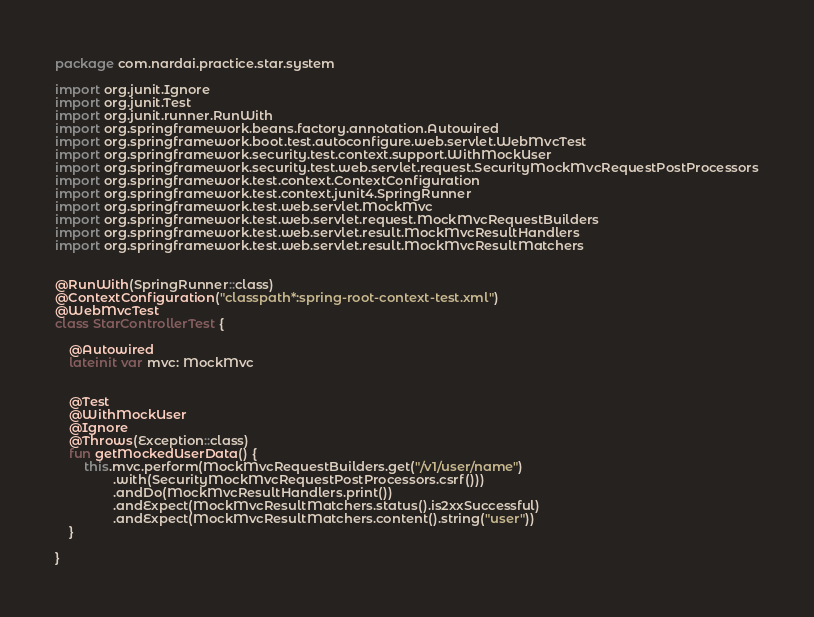<code> <loc_0><loc_0><loc_500><loc_500><_Kotlin_>package com.nardai.practice.star.system

import org.junit.Ignore
import org.junit.Test
import org.junit.runner.RunWith
import org.springframework.beans.factory.annotation.Autowired
import org.springframework.boot.test.autoconfigure.web.servlet.WebMvcTest
import org.springframework.security.test.context.support.WithMockUser
import org.springframework.security.test.web.servlet.request.SecurityMockMvcRequestPostProcessors
import org.springframework.test.context.ContextConfiguration
import org.springframework.test.context.junit4.SpringRunner
import org.springframework.test.web.servlet.MockMvc
import org.springframework.test.web.servlet.request.MockMvcRequestBuilders
import org.springframework.test.web.servlet.result.MockMvcResultHandlers
import org.springframework.test.web.servlet.result.MockMvcResultMatchers


@RunWith(SpringRunner::class)
@ContextConfiguration("classpath*:spring-root-context-test.xml")
@WebMvcTest
class StarControllerTest {

    @Autowired
    lateinit var mvc: MockMvc


    @Test
    @WithMockUser
    @Ignore
    @Throws(Exception::class)
    fun getMockedUserData() {
        this.mvc.perform(MockMvcRequestBuilders.get("/v1/user/name")
                .with(SecurityMockMvcRequestPostProcessors.csrf()))
                .andDo(MockMvcResultHandlers.print())
                .andExpect(MockMvcResultMatchers.status().is2xxSuccessful)
                .andExpect(MockMvcResultMatchers.content().string("user"))
    }

}
</code> 